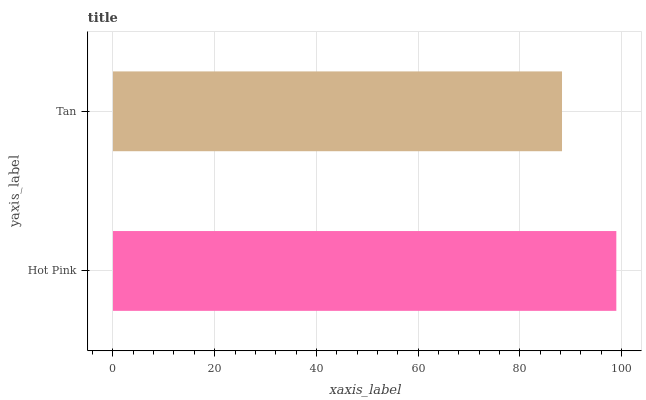Is Tan the minimum?
Answer yes or no. Yes. Is Hot Pink the maximum?
Answer yes or no. Yes. Is Tan the maximum?
Answer yes or no. No. Is Hot Pink greater than Tan?
Answer yes or no. Yes. Is Tan less than Hot Pink?
Answer yes or no. Yes. Is Tan greater than Hot Pink?
Answer yes or no. No. Is Hot Pink less than Tan?
Answer yes or no. No. Is Hot Pink the high median?
Answer yes or no. Yes. Is Tan the low median?
Answer yes or no. Yes. Is Tan the high median?
Answer yes or no. No. Is Hot Pink the low median?
Answer yes or no. No. 